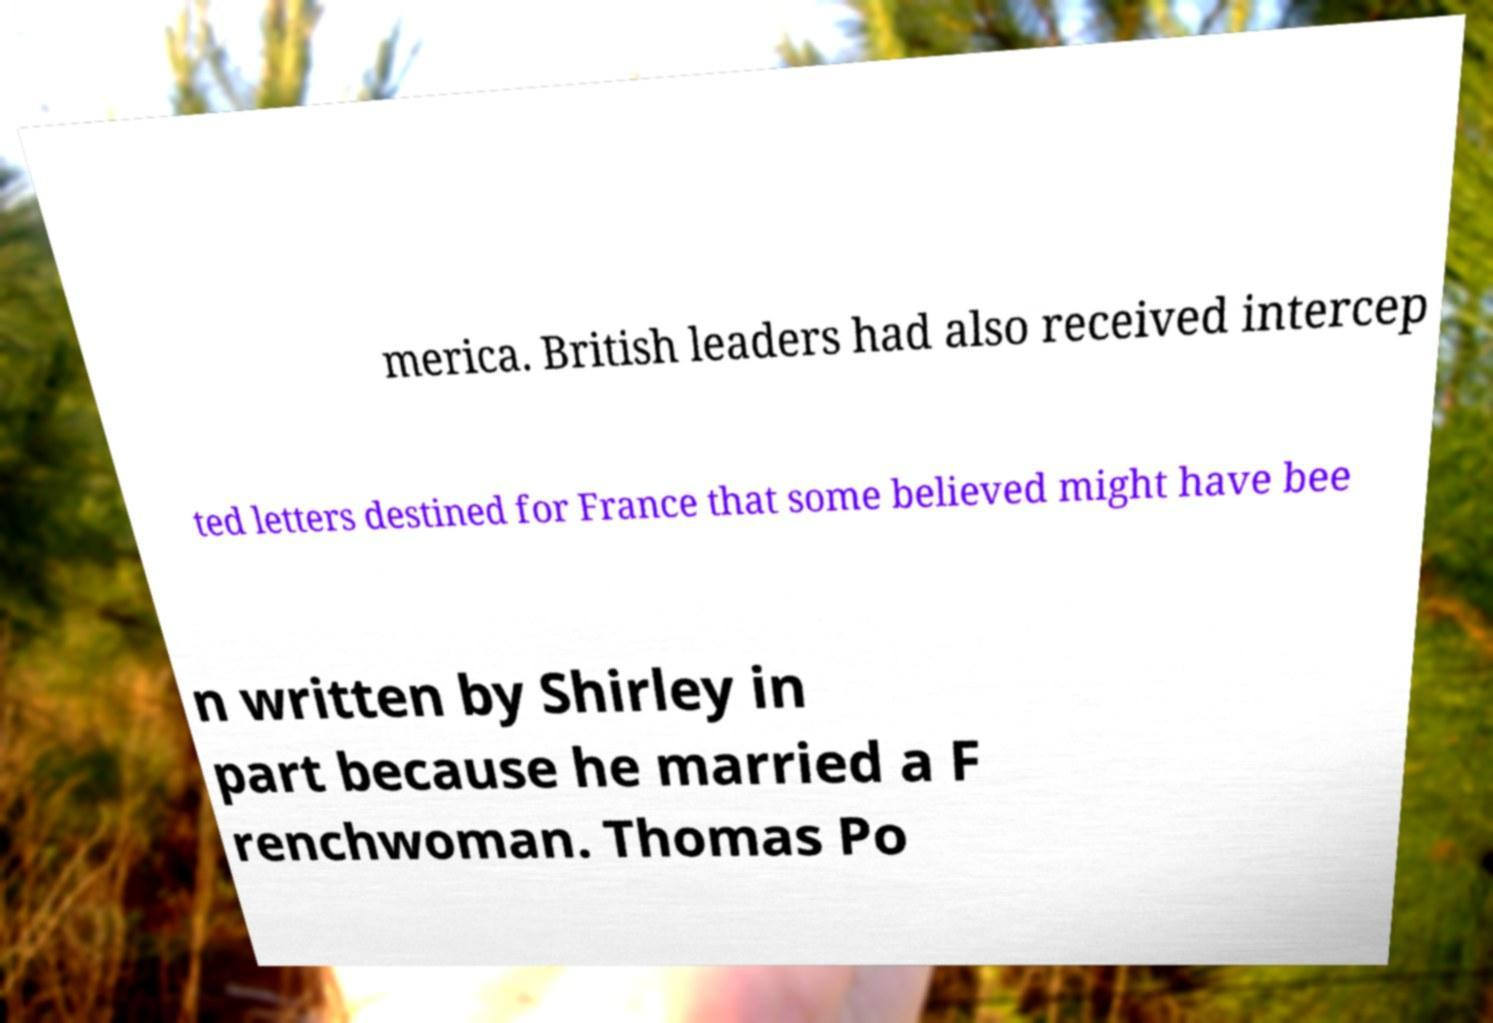I need the written content from this picture converted into text. Can you do that? merica. British leaders had also received intercep ted letters destined for France that some believed might have bee n written by Shirley in part because he married a F renchwoman. Thomas Po 